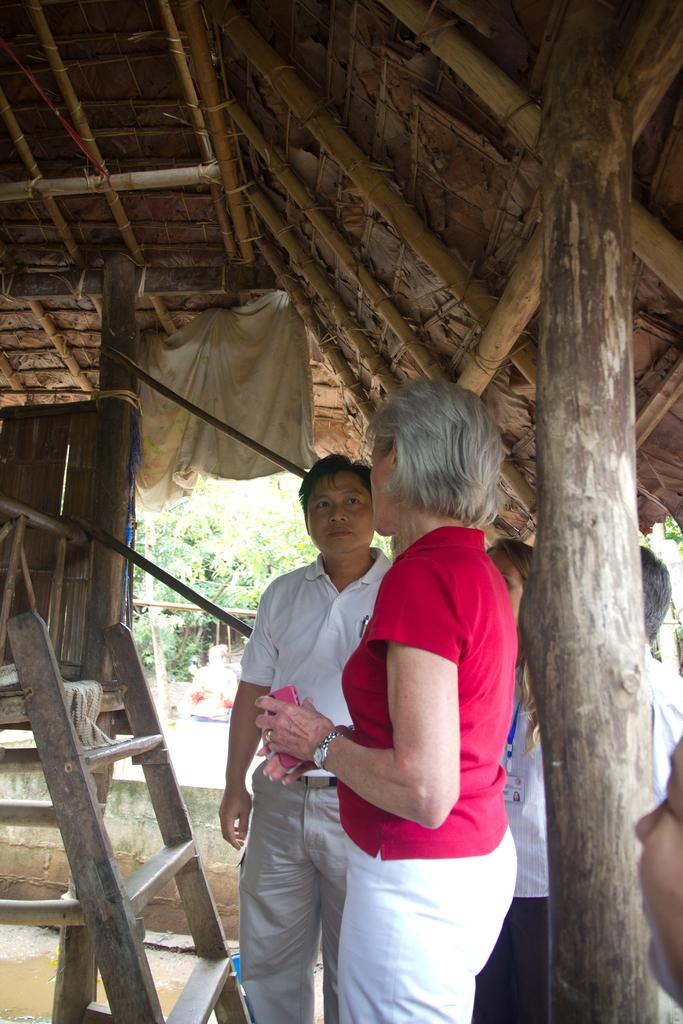How many people are present in the image? There are two people, a man and a woman, present in the image. What are the man and woman doing in the image? Both the man and woman are standing under a roof. What object can be seen near the roof in the image? There is a cloth tied to the roof. What architectural feature is visible in the background of the image? There is a wall in the background. What type of natural environment is visible in the background of the image? Trees are visible in the background. How many ghosts can be seen in the image? There are no ghosts present in the image. What is the amount of good-bye messages written on the cloth tied to the roof? There is no indication of any good-bye messages on the cloth tied to the roof in the image. 